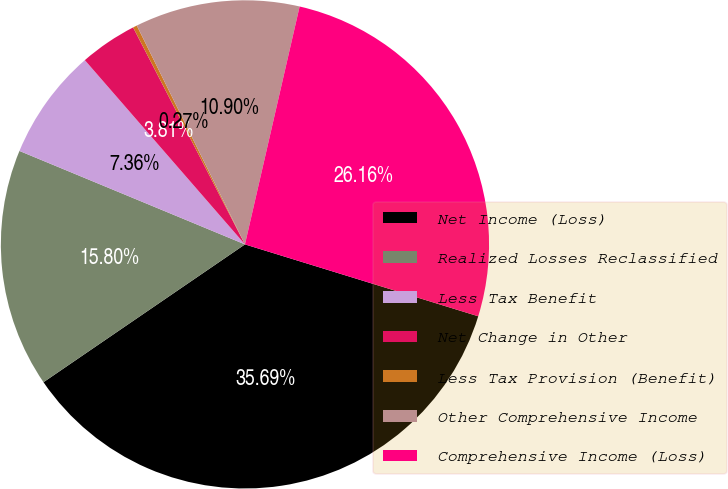Convert chart. <chart><loc_0><loc_0><loc_500><loc_500><pie_chart><fcel>Net Income (Loss)<fcel>Realized Losses Reclassified<fcel>Less Tax Benefit<fcel>Net Change in Other<fcel>Less Tax Provision (Benefit)<fcel>Other Comprehensive Income<fcel>Comprehensive Income (Loss)<nl><fcel>35.69%<fcel>15.8%<fcel>7.36%<fcel>3.81%<fcel>0.27%<fcel>10.9%<fcel>26.16%<nl></chart> 